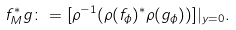Convert formula to latex. <formula><loc_0><loc_0><loc_500><loc_500>f ^ { * } _ { M } g \colon = [ \rho ^ { - 1 } ( \rho ( f _ { \phi } ) ^ { * } \rho ( g _ { \phi } ) ) ] | _ { y = 0 } .</formula> 